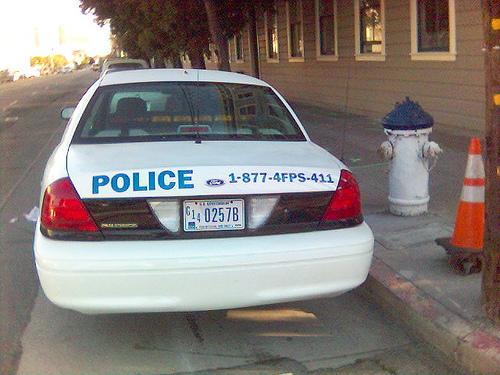What colors are on top of the police car?
Quick response, please. White. Who owns this vehicle?
Concise answer only. Police. Name the type of license plate on the white car?
Write a very short answer. Government. What state police is this?
Short answer required. Connecticut. 